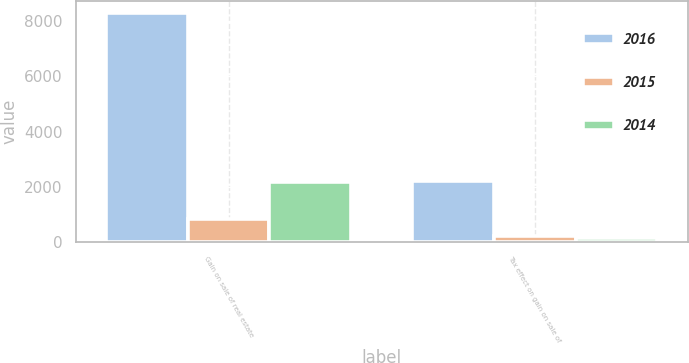<chart> <loc_0><loc_0><loc_500><loc_500><stacked_bar_chart><ecel><fcel>Gain on sale of real estate<fcel>Tax effect on gain on sale of<nl><fcel>2016<fcel>8307<fcel>2205<nl><fcel>2015<fcel>850<fcel>209<nl><fcel>2014<fcel>2180<fcel>130<nl></chart> 